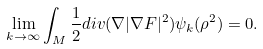<formula> <loc_0><loc_0><loc_500><loc_500>\lim _ { k \rightarrow \infty } \int _ { M } \frac { 1 } { 2 } d i v ( \nabla | \nabla F | ^ { 2 } ) \psi _ { k } ( \rho ^ { 2 } ) = 0 .</formula> 